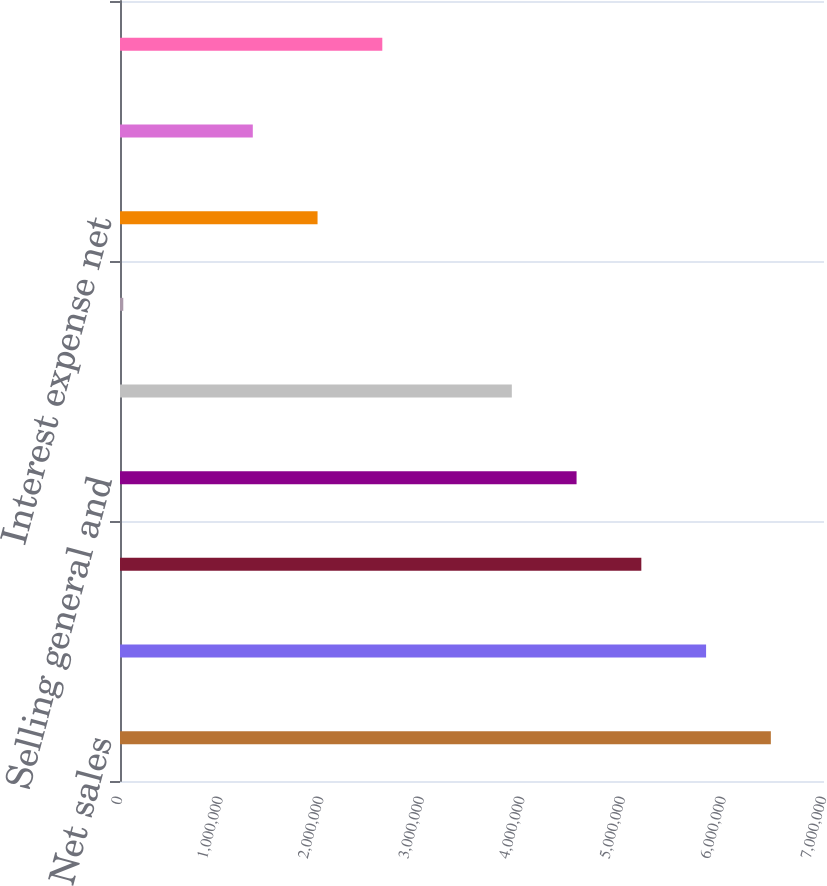Convert chart to OTSL. <chart><loc_0><loc_0><loc_500><loc_500><bar_chart><fcel>Net sales<fcel>Cost of sales<fcel>Gross profit<fcel>Selling general and<fcel>Operating profit<fcel>Other expenses<fcel>Interest expense net<fcel>Income from continuing<fcel>Income tax expense<nl><fcel>6.47141e+06<fcel>5.82753e+06<fcel>5.18366e+06<fcel>4.53978e+06<fcel>3.8959e+06<fcel>32645<fcel>1.96427e+06<fcel>1.3204e+06<fcel>2.60815e+06<nl></chart> 